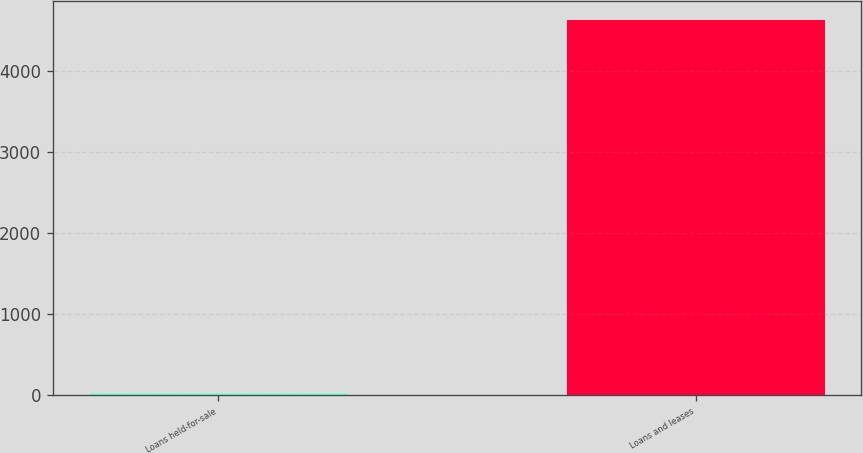Convert chart. <chart><loc_0><loc_0><loc_500><loc_500><bar_chart><fcel>Loans held-for-sale<fcel>Loans and leases<nl><fcel>30<fcel>4636<nl></chart> 